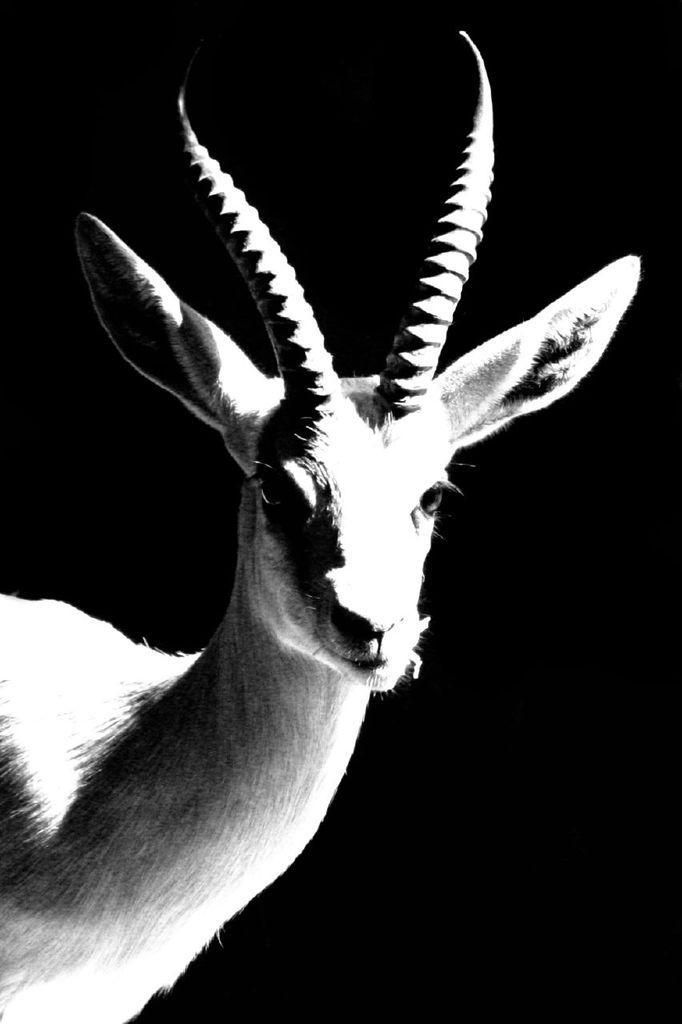In one or two sentences, can you explain what this image depicts? In this image we can see one animal and there is a black background. 